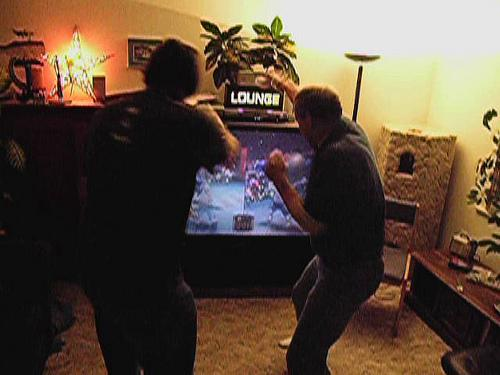Question: what are the people doing?
Choices:
A. Working.
B. Shoppng.
C. Playing a video game.
D. Kissing.
Answer with the letter. Answer: C Question: why are the people posed in front of the tv?
Choices:
A. They are watching it.
B. They are waiting for a show.
C. They are browsing channels.
D. They are playing a video game.
Answer with the letter. Answer: D Question: what shape is lit up on the shelf?
Choices:
A. A circle.
B. A square.
C. A triangle.
D. A star.
Answer with the letter. Answer: D Question: where is the lighted star?
Choices:
A. On the wall.
B. On the ceiling.
C. On the desk.
D. On the shelf.
Answer with the letter. Answer: D Question: who is playing a video game?
Choices:
A. The man.
B. The woman.
C. The boy.
D. The two people.
Answer with the letter. Answer: D 